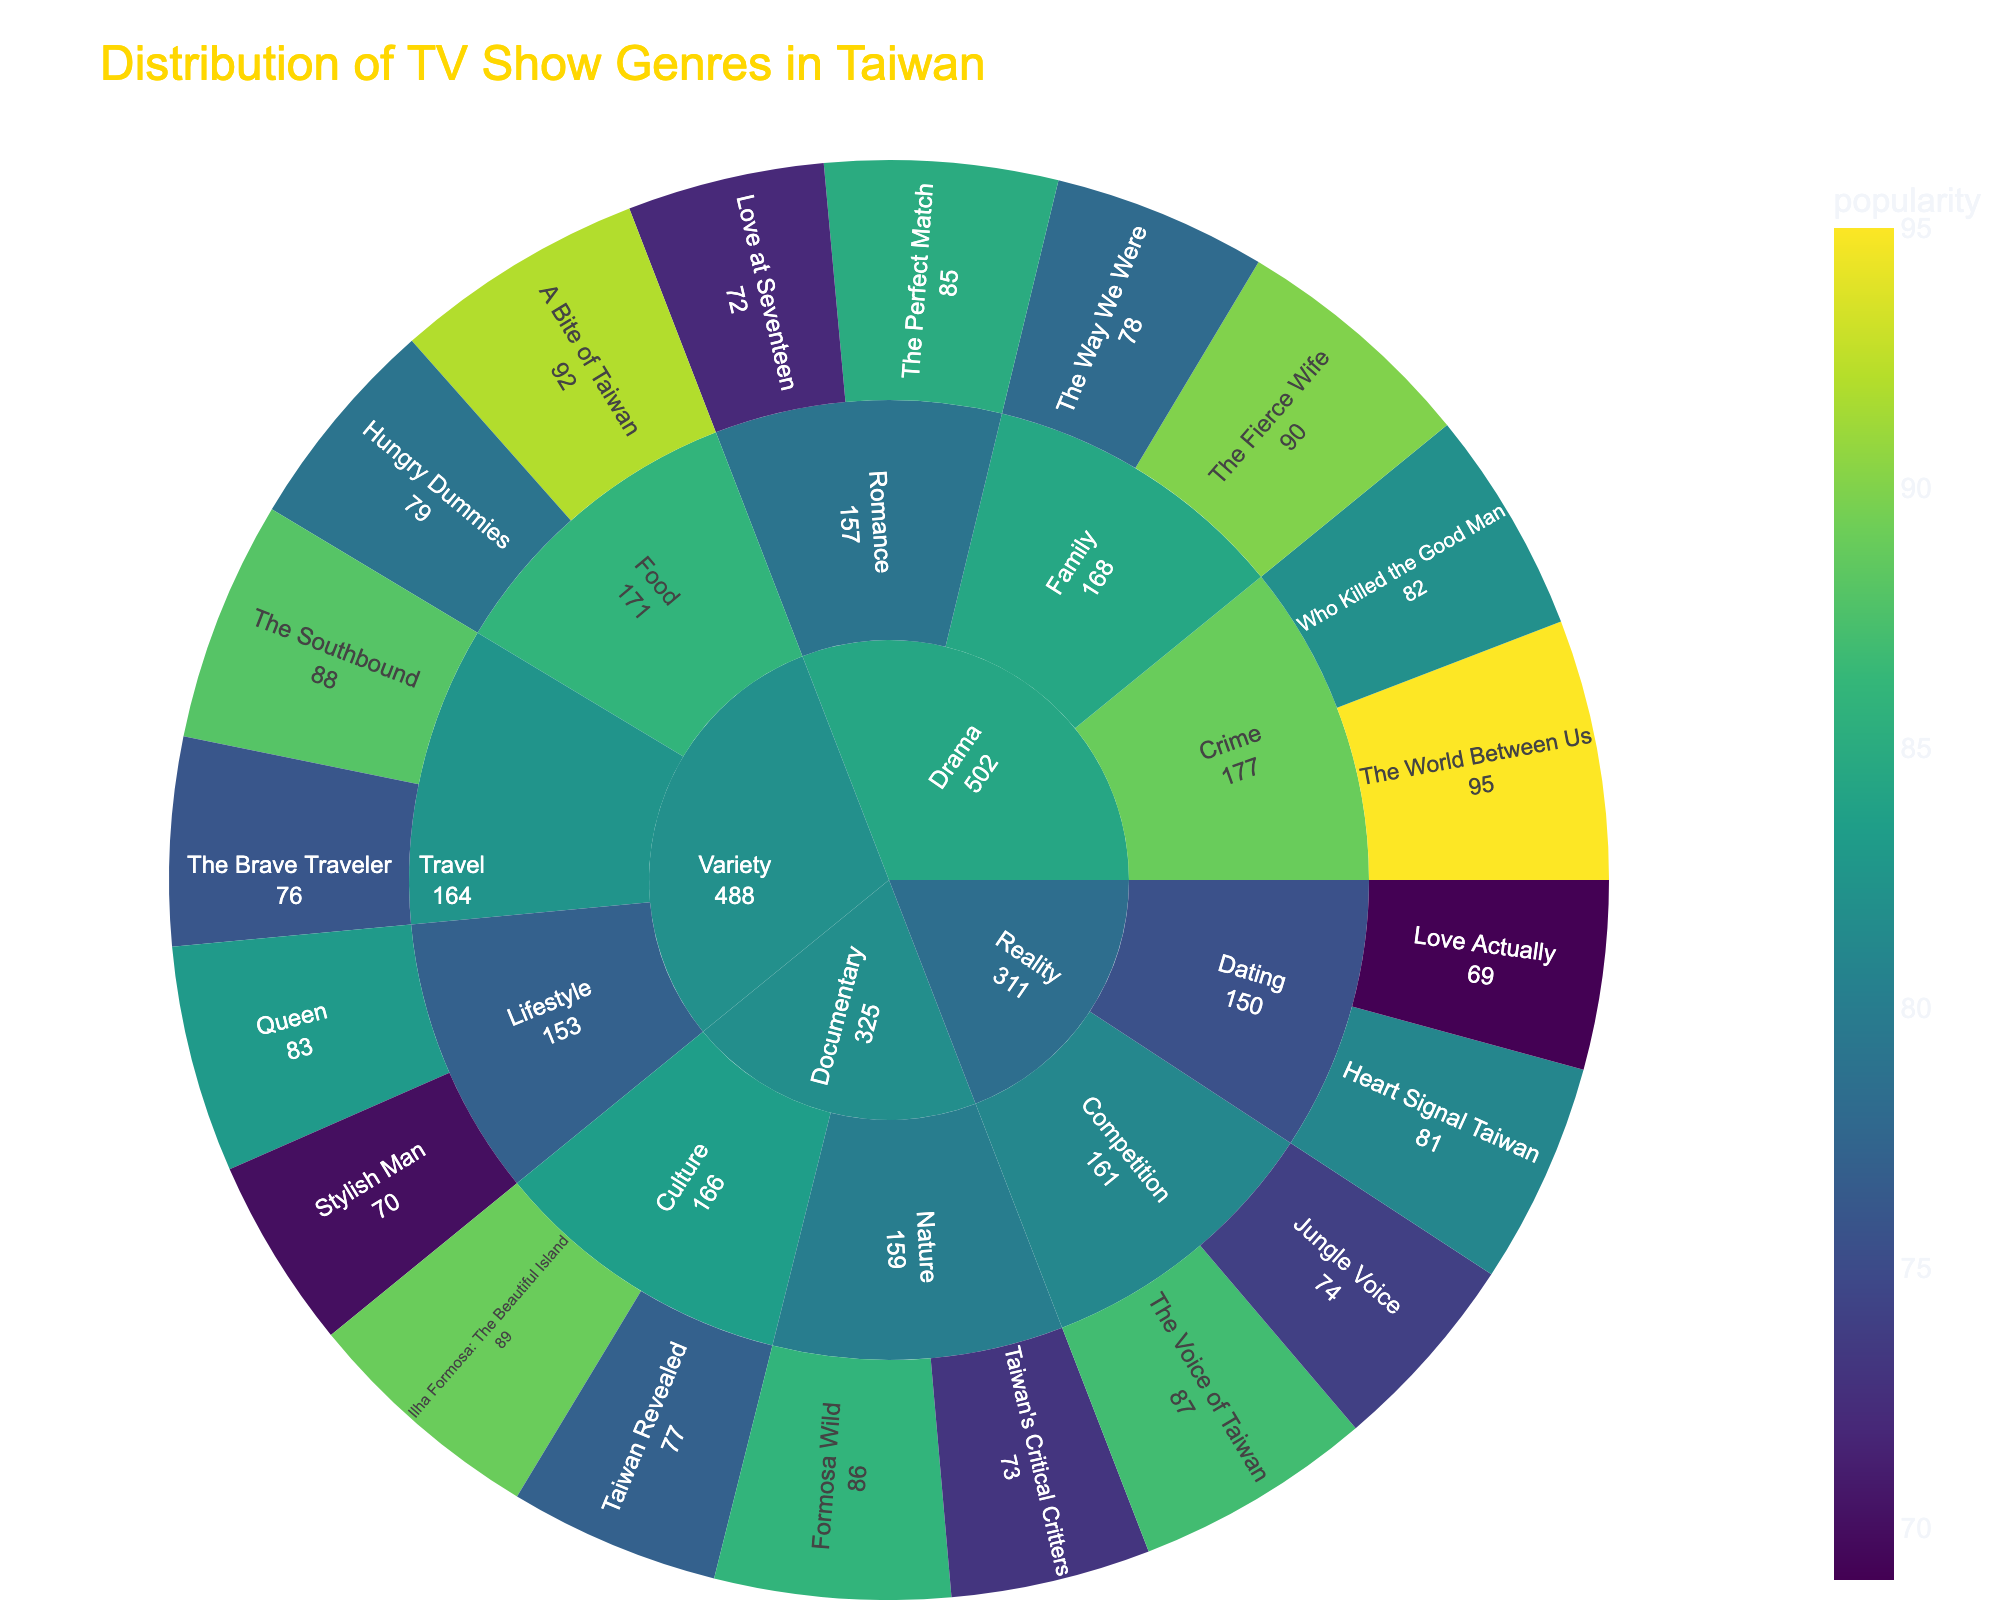What's the genre with the highest popularity in the Crime subcategory? In the Sunburst Plot, navigate to Drama > Crime, and compare the popularity values of the shows under Crime. The World Between Us has a popularity of 95.
Answer: The World Between Us Which subcategory in the Documentary category has the highest popularity? In the Sunburst Plot, navigate to the Documentary category. Compare the two subcategories Nature and Culture. The highest popularity in Culture is for Ilha Formosa: The Beautiful Island (89), which is higher than the highest in Nature (Formosa Wild: 86).
Answer: Culture How many shows have a popularity of over 80 in the Variety category? In the Sunburst Plot, navigate to the Variety category. Count the shows with a popularity over 80: The Southbound (88), Queen (83), and A Bite of Taiwan (92). There are three such shows.
Answer: 3 What's the least popular show in the Reality category? In the Sunburst Plot, navigate to the Reality category. Compare the popularity values of the shows and identify the minimum. Love Actually has the lowest popularity of 69.
Answer: Love Actually In the Drama category, which subcategory has a higher average popularity: Romance or Family? Calculate the average popularity for both subcategories. Romance: (85 + 72)/2 = 78.5, Family: (90 + 78)/2 = 84. Family has a higher average popularity.
Answer: Family What’s the total popularity of all shows under the Travel subcategory? Sum the popularity values of all shows under Travel: The Southbound (88) + The Brave Traveler (76) = 164.
Answer: 164 Which category has more shows with a popularity score above 85? Count the shows in each category with popularity > 85. Drama has two (The World Between Us, The Fierce Wife), Variety has two (The Southbound, A Bite of Taiwan), Reality has one (The Voice of Taiwan), and Documentary has two (Formosa Wild, Ilha Formosa: The Beautiful Island). Drama, Variety, and Documentary each have two.
Answer: Drama, Variety, Documentary (tie) Which subcategory has the widest range of popularity scores in the Drama category? Calculate the range for each subcategory in Drama. Romance: 85 - 72 = 13; Family: 90 - 78 = 12; Crime: 95 - 82 = 13. Romance and Crime both have the widest range of 13.
Answer: Romance, Crime (tie) If you sum the popularity of all shows in the Culture subcategory, what is the total? Sum the popularity values of all shows under Culture: Ilha Formosa: The Beautiful Island (89) + Taiwan Revealed (77) = 166.
Answer: 166 